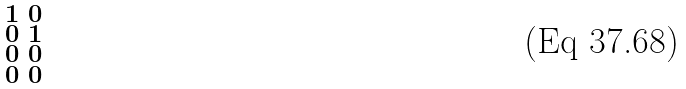Convert formula to latex. <formula><loc_0><loc_0><loc_500><loc_500>\begin{smallmatrix} 1 & 0 \\ 0 & 1 \\ 0 & 0 \\ 0 & 0 \end{smallmatrix}</formula> 